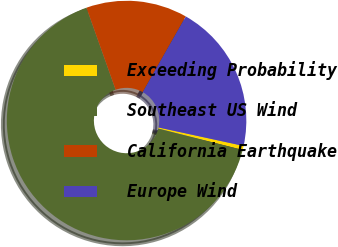Convert chart. <chart><loc_0><loc_0><loc_500><loc_500><pie_chart><fcel>Exceeding Probability<fcel>Southeast US Wind<fcel>California Earthquake<fcel>Europe Wind<nl><fcel>0.55%<fcel>65.61%<fcel>13.67%<fcel>20.17%<nl></chart> 